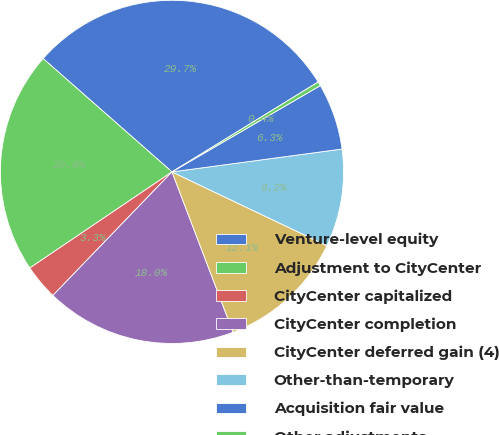<chart> <loc_0><loc_0><loc_500><loc_500><pie_chart><fcel>Venture-level equity<fcel>Adjustment to CityCenter<fcel>CityCenter capitalized<fcel>CityCenter completion<fcel>CityCenter deferred gain (4)<fcel>Other-than-temporary<fcel>Acquisition fair value<fcel>Other adjustments<nl><fcel>29.74%<fcel>20.94%<fcel>3.33%<fcel>18.0%<fcel>12.13%<fcel>9.2%<fcel>6.26%<fcel>0.39%<nl></chart> 